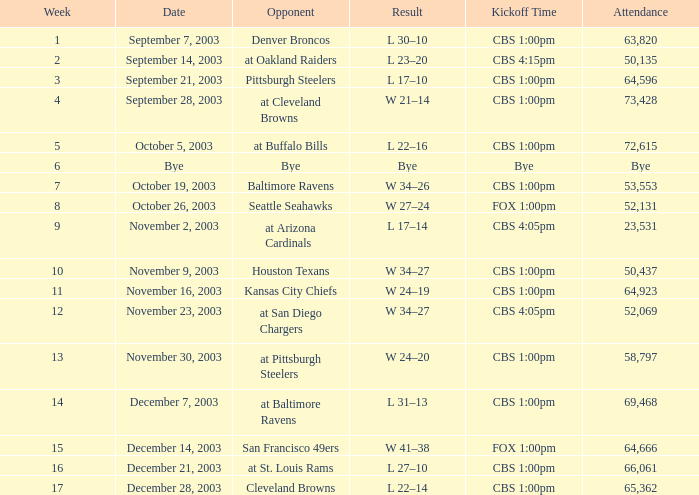What is the median number of weeks that the competitor was the denver broncos? 1.0. 